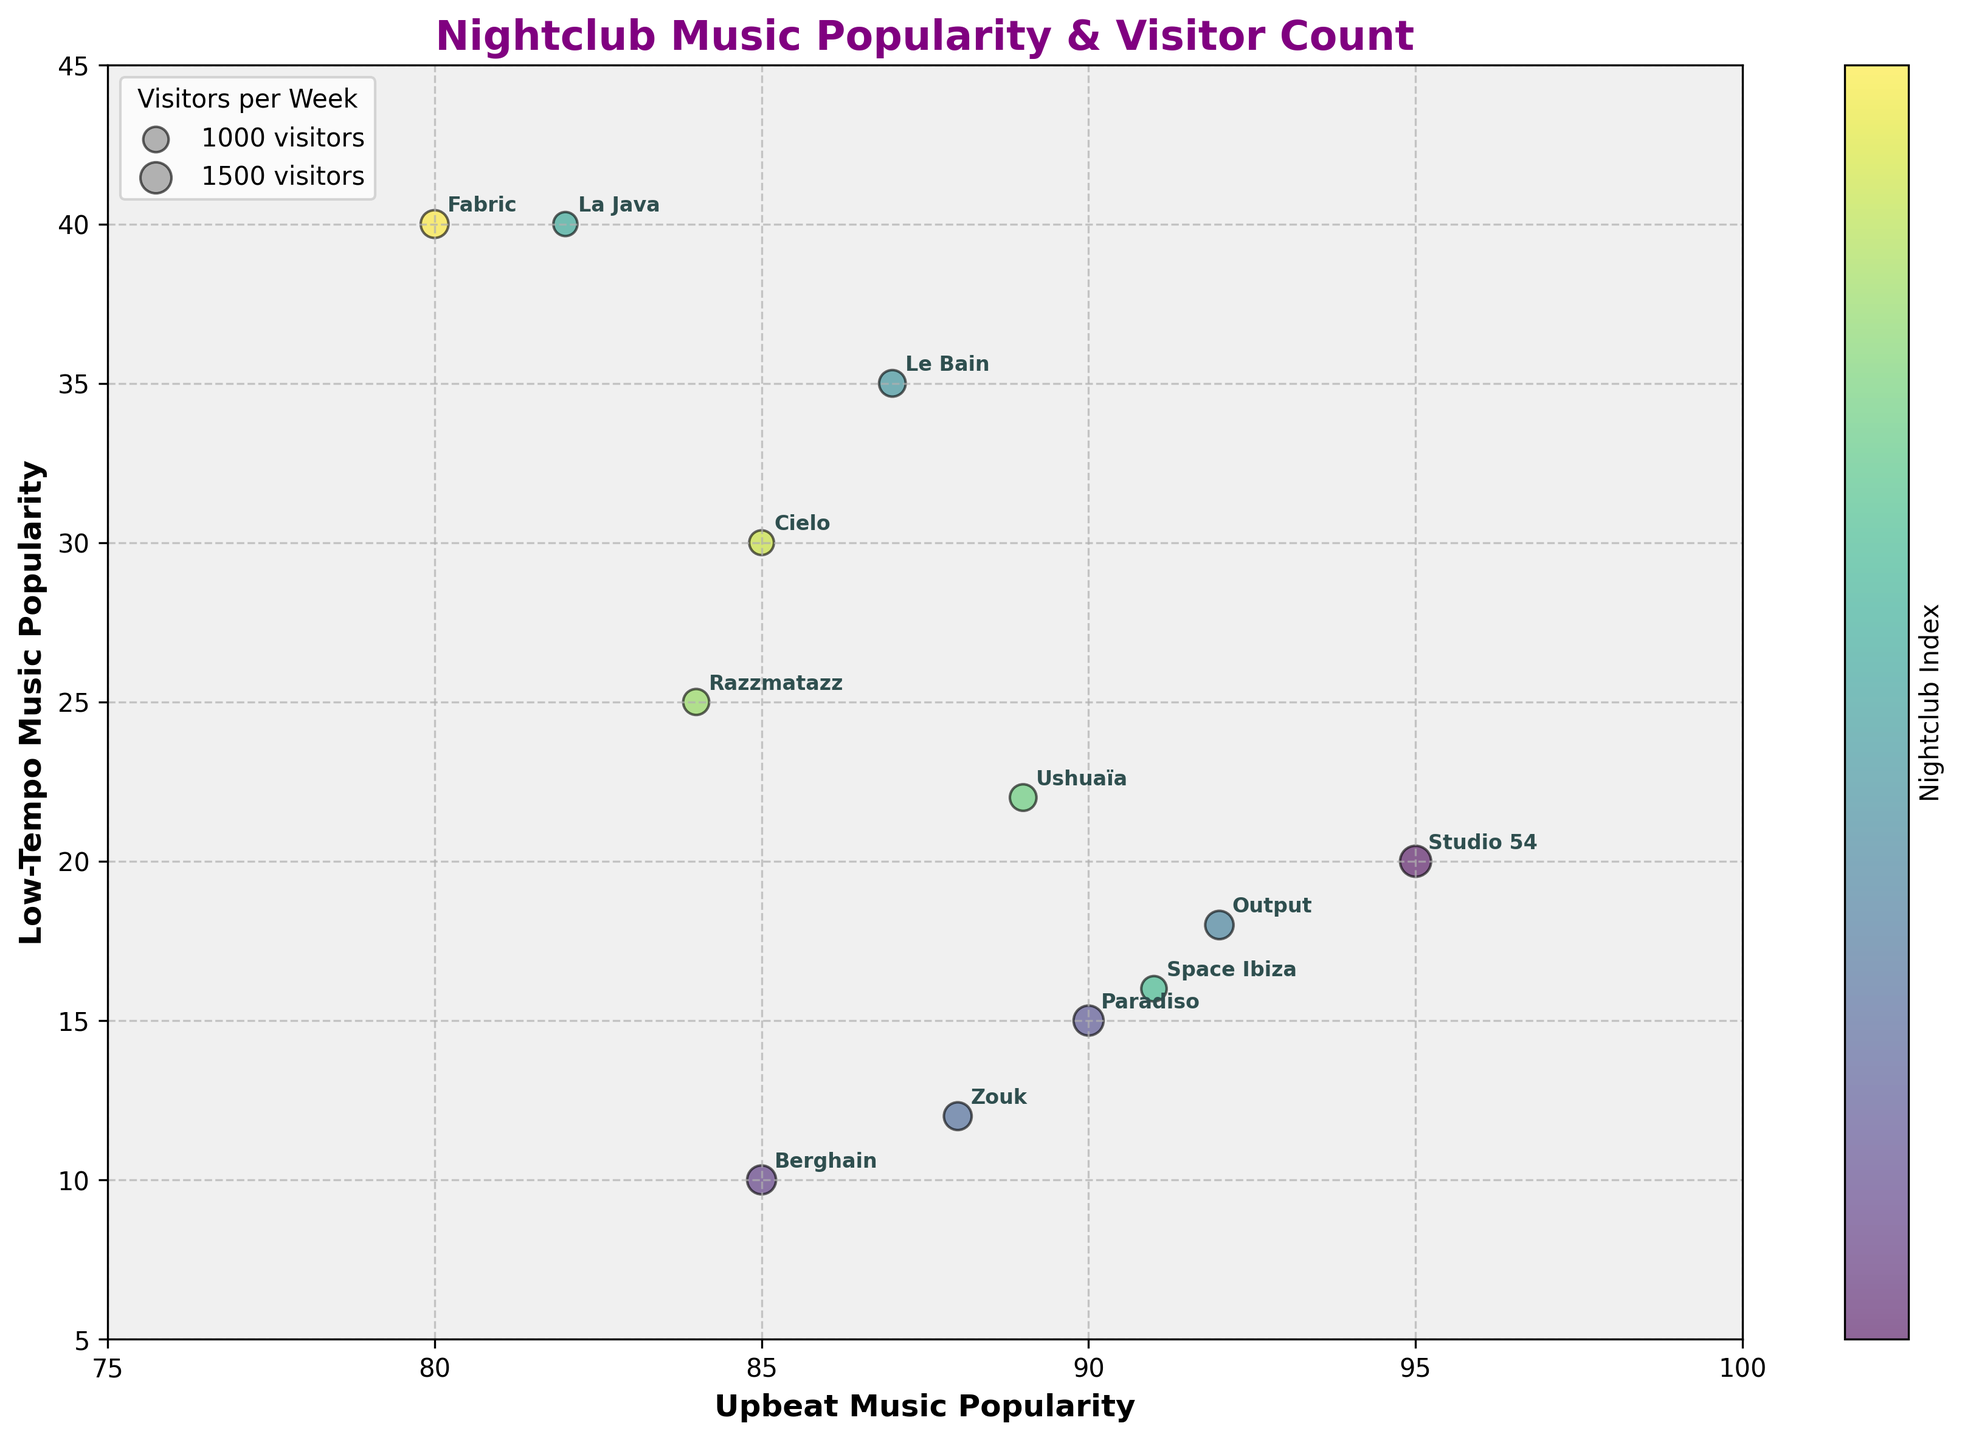What's the title of the figure? The title is located at the top of the figure.
Answer: Nightclub Music Popularity & Visitor Count What does the x-axis represent? The x-axis label is clearly mentioned at the bottom of the axis.
Answer: Upbeat Music Popularity What range does the x-axis cover? Observing the left and right ends of the x-axis shows the range.
Answer: 75 to 100 How many nightclubs have an upbeat music popularity score higher than 90? Look at the x-axis and count the data points that have an x-value greater than 90.
Answer: 5 Between 'Studio 54' and 'Le Bain', which nightclub has a higher low-tempo music popularity? Compare the y-values of 'Studio 54' and 'Le Bain'.
Answer: Le Bain What's the average visitors per week for nightclubs in New York? Identify the nightclubs in New York, sum their visitors per week, and divide by the number of these nightclubs. (Studio 54 = 1500, Le Bain = 1100, Cielo = 950) Average = (1500+1100+950)/3 = 1183.33
Answer: 1183.33 Which nightclub has the smallest bubble and what does that signify? Observe the sizes of the bubbles and identify the smallest one. Check the legend to understand the size representation.
Answer: La Java; it signifies the lowest number of visitors per week among the listed nightclubs Is there any nightclub with both high upbeat music popularity and low low-tempo music popularity? High upbeat music popularity (>85) and low low-tempo music popularity (<20). Identify any overlaps of these criteria in the plot.
Answer: Yes, Studio 54 and Berghain Which city has the most representation in the chart? Count the number of nightclubs per city based on the annotations.
Answer: New York Between 'Fabric' and 'Razzmatazz', which one has a greater number of visitors per week and by how much? Compare the sizes of the bubbles and refer to the size legend. Fabric: 1200 visitors, Razzmatazz: 1050 visitors. Difference = 1200 - 1050 = 150
Answer: Fabric by 150 visitors 